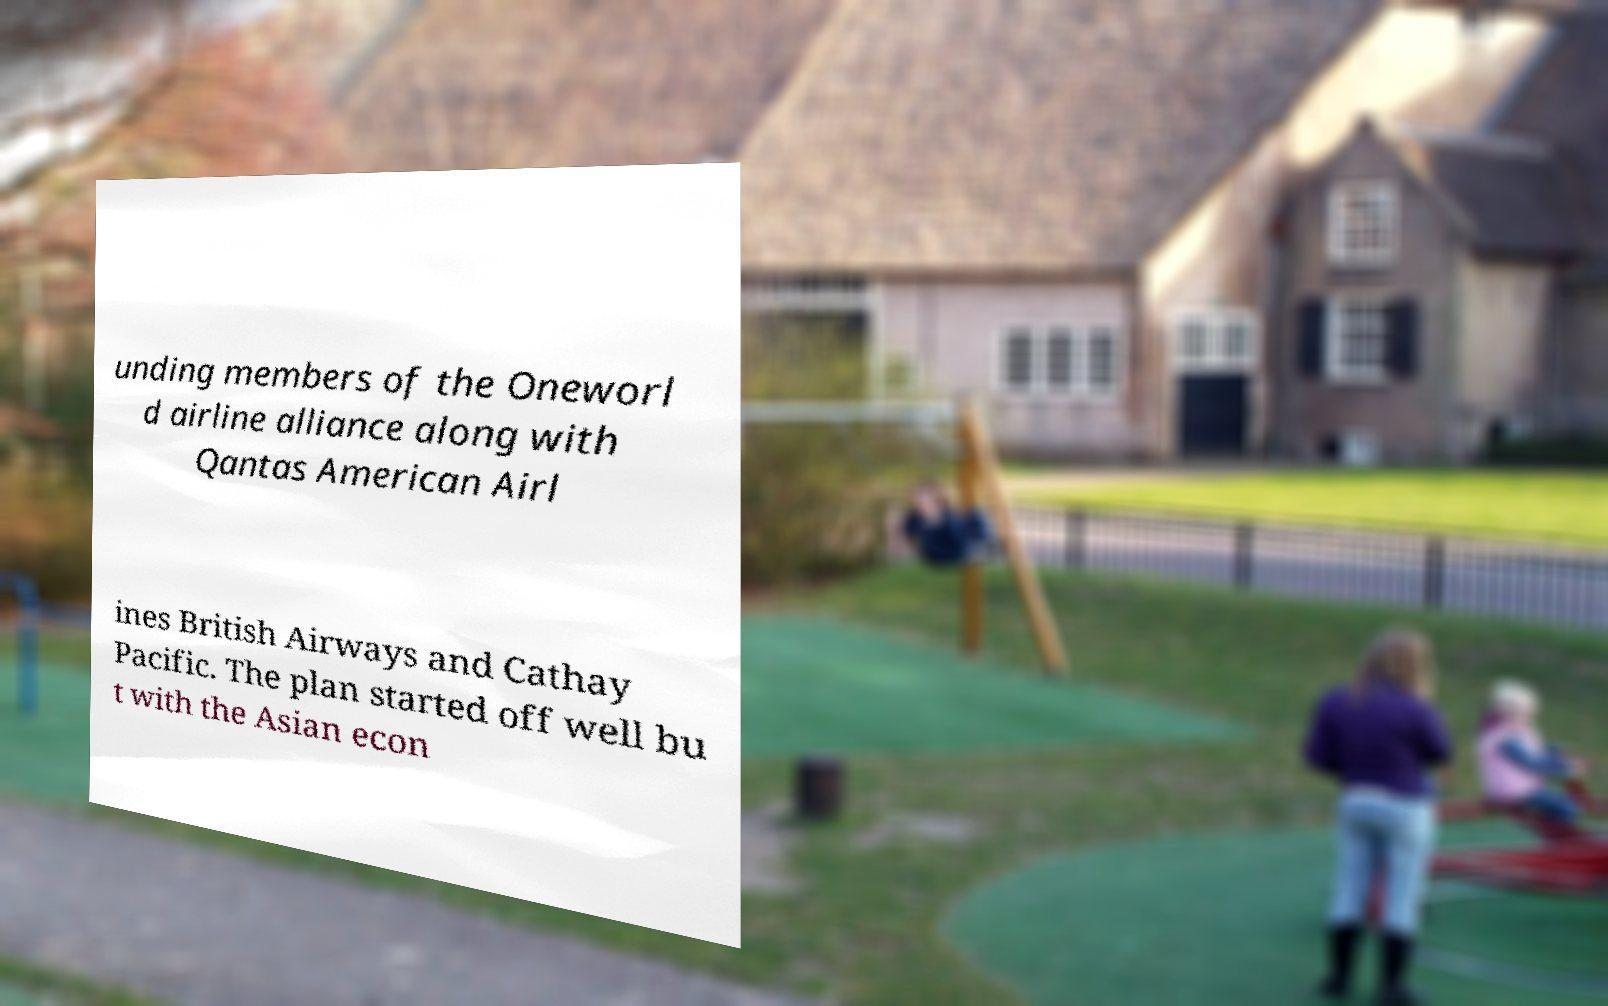Please read and relay the text visible in this image. What does it say? unding members of the Oneworl d airline alliance along with Qantas American Airl ines British Airways and Cathay Pacific. The plan started off well bu t with the Asian econ 